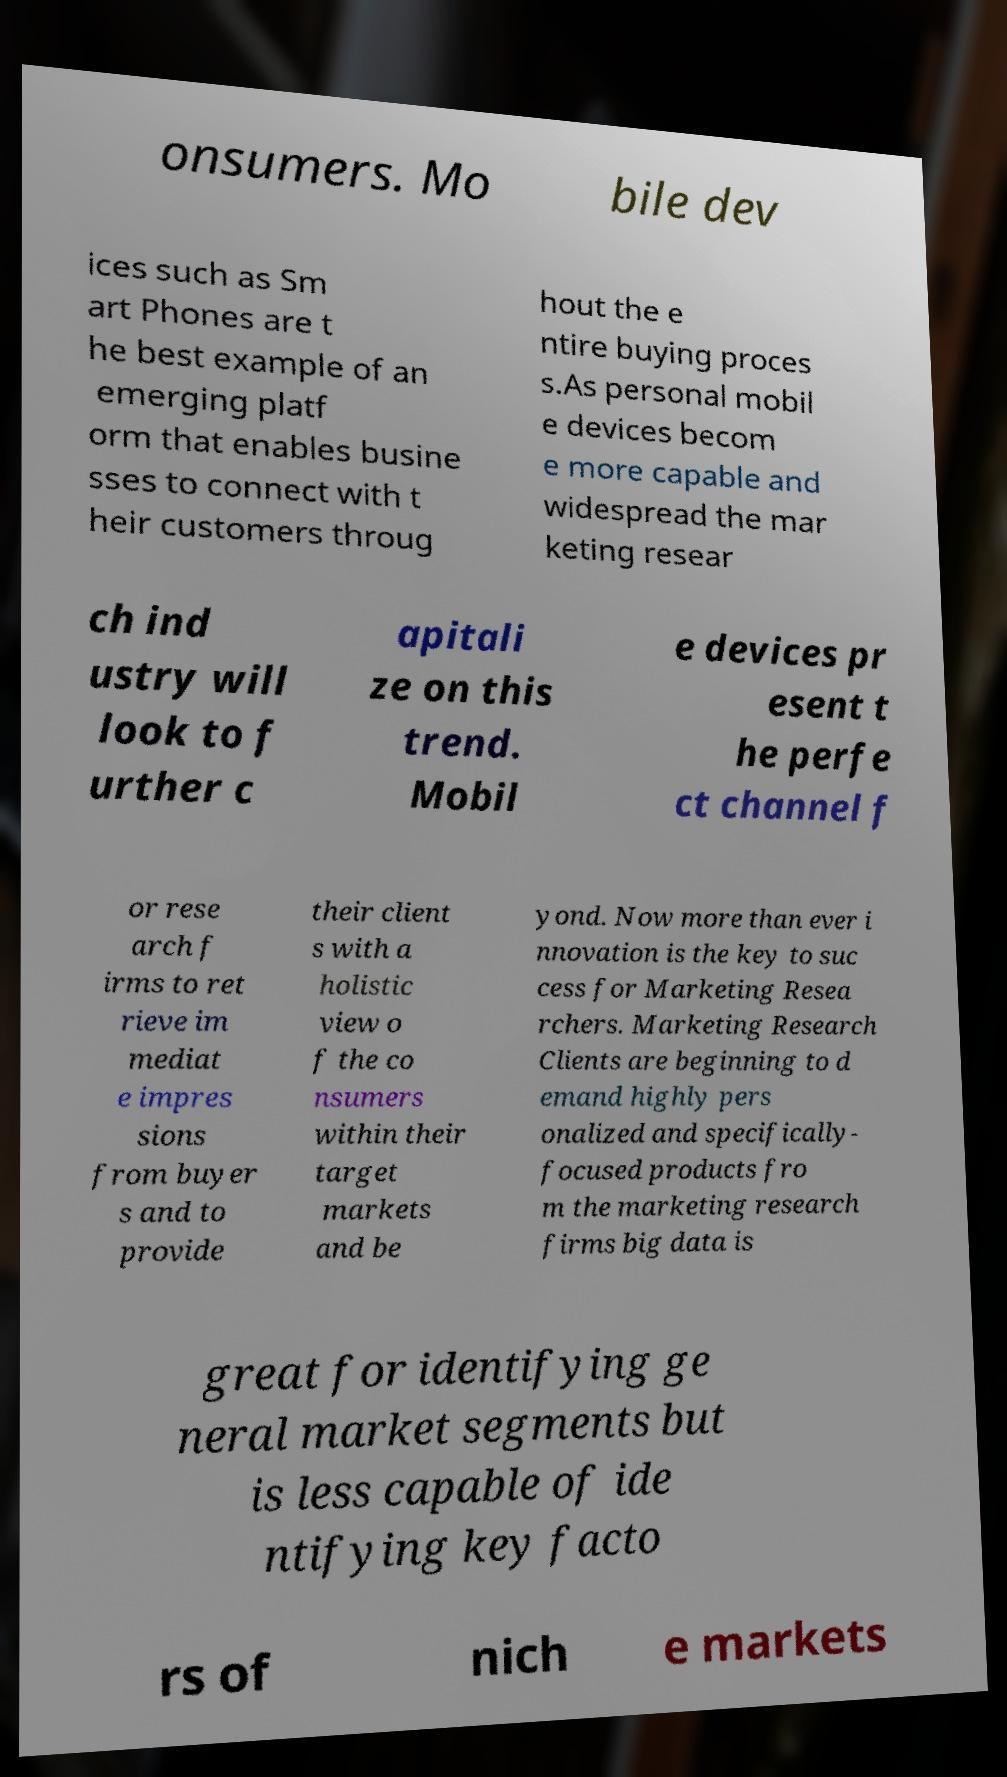Please identify and transcribe the text found in this image. onsumers. Mo bile dev ices such as Sm art Phones are t he best example of an emerging platf orm that enables busine sses to connect with t heir customers throug hout the e ntire buying proces s.As personal mobil e devices becom e more capable and widespread the mar keting resear ch ind ustry will look to f urther c apitali ze on this trend. Mobil e devices pr esent t he perfe ct channel f or rese arch f irms to ret rieve im mediat e impres sions from buyer s and to provide their client s with a holistic view o f the co nsumers within their target markets and be yond. Now more than ever i nnovation is the key to suc cess for Marketing Resea rchers. Marketing Research Clients are beginning to d emand highly pers onalized and specifically- focused products fro m the marketing research firms big data is great for identifying ge neral market segments but is less capable of ide ntifying key facto rs of nich e markets 